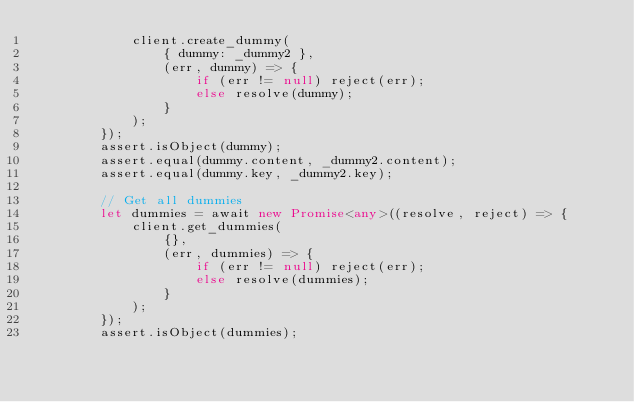Convert code to text. <code><loc_0><loc_0><loc_500><loc_500><_TypeScript_>            client.create_dummy(
                { dummy: _dummy2 },
                (err, dummy) => {
                    if (err != null) reject(err);
                    else resolve(dummy);
                }
            );
        });
        assert.isObject(dummy);
        assert.equal(dummy.content, _dummy2.content);
        assert.equal(dummy.key, _dummy2.key);

        // Get all dummies
        let dummies = await new Promise<any>((resolve, reject) => {
            client.get_dummies(
                {},
                (err, dummies) => {
                    if (err != null) reject(err);
                    else resolve(dummies);
                }
            );
        });
        assert.isObject(dummies);</code> 